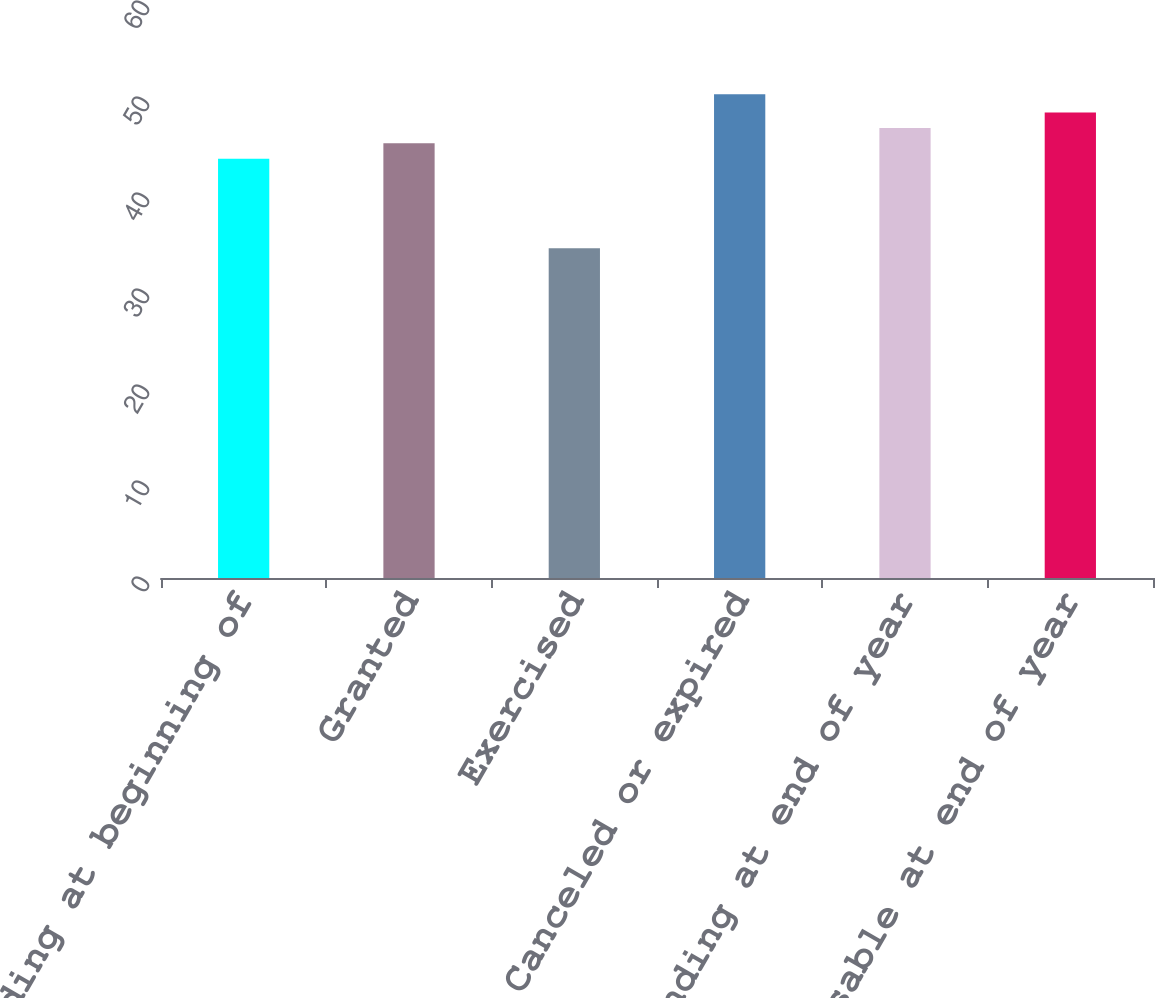Convert chart. <chart><loc_0><loc_0><loc_500><loc_500><bar_chart><fcel>Outstanding at beginning of<fcel>Granted<fcel>Exercised<fcel>Canceled or expired<fcel>Outstanding at end of year<fcel>Exercisable at end of year<nl><fcel>43.68<fcel>45.28<fcel>34.35<fcel>50.38<fcel>46.88<fcel>48.48<nl></chart> 